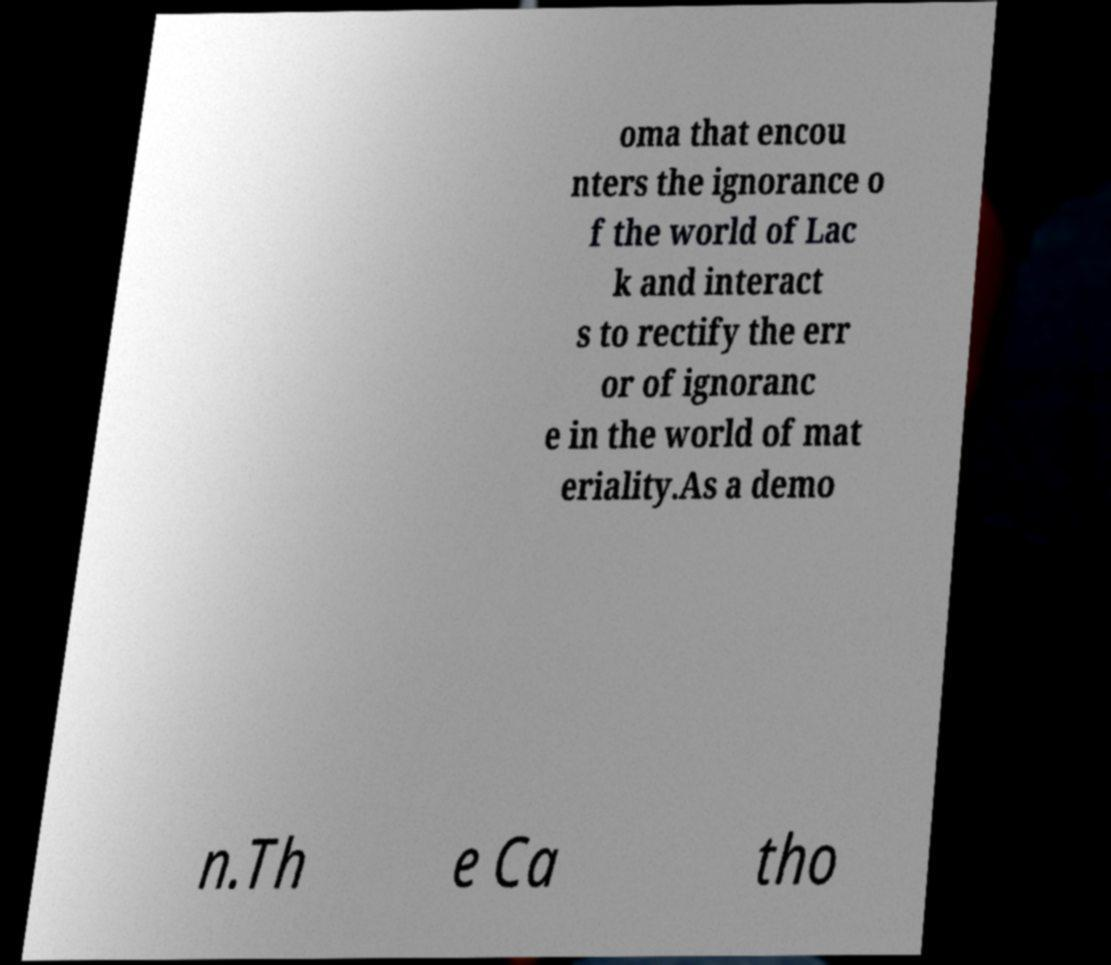Could you extract and type out the text from this image? oma that encou nters the ignorance o f the world of Lac k and interact s to rectify the err or of ignoranc e in the world of mat eriality.As a demo n.Th e Ca tho 